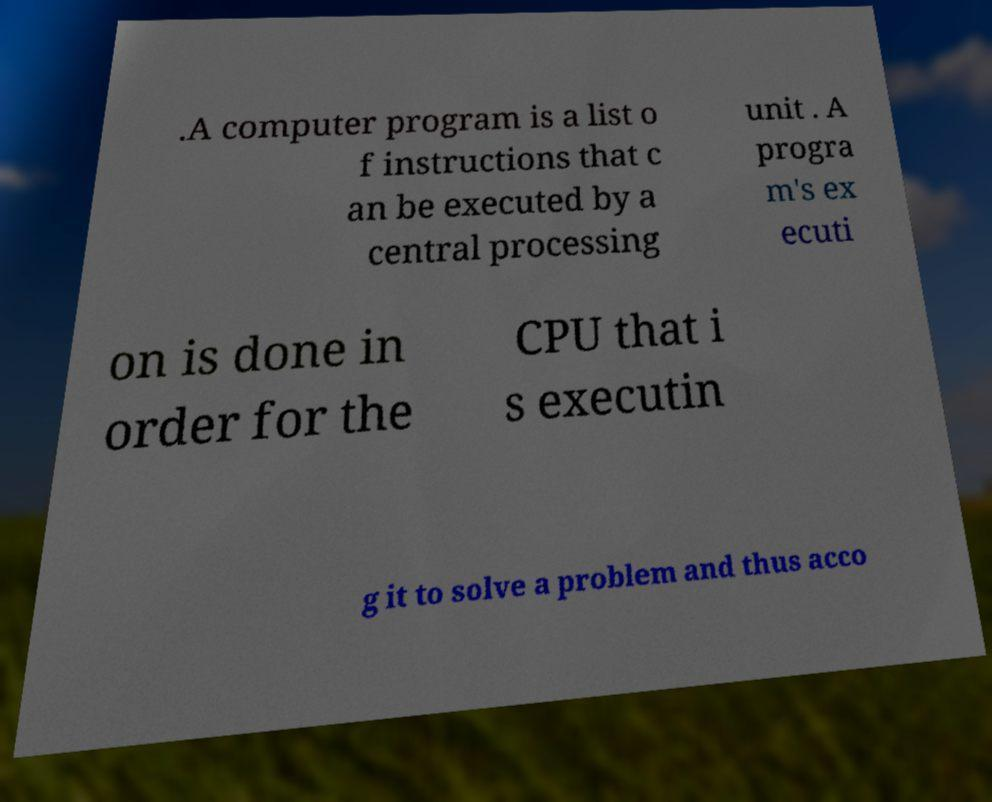Could you extract and type out the text from this image? .A computer program is a list o f instructions that c an be executed by a central processing unit . A progra m's ex ecuti on is done in order for the CPU that i s executin g it to solve a problem and thus acco 